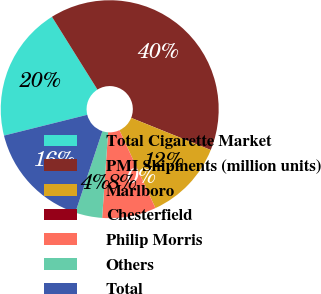<chart> <loc_0><loc_0><loc_500><loc_500><pie_chart><fcel>Total Cigarette Market<fcel>PMI Shipments (million units)<fcel>Marlboro<fcel>Chesterfield<fcel>Philip Morris<fcel>Others<fcel>Total<nl><fcel>20.0%<fcel>39.99%<fcel>12.0%<fcel>0.0%<fcel>8.0%<fcel>4.0%<fcel>16.0%<nl></chart> 